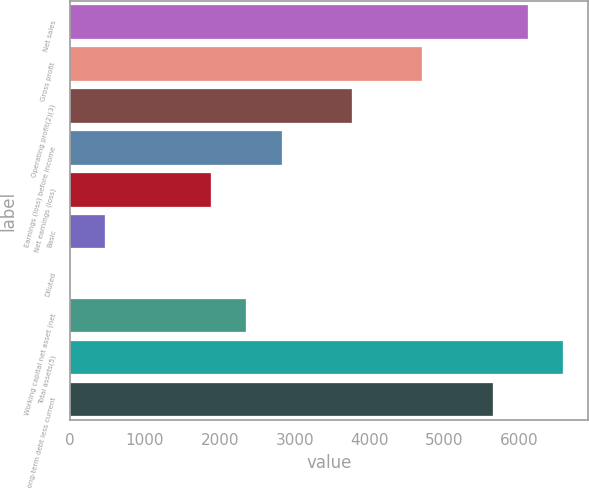Convert chart to OTSL. <chart><loc_0><loc_0><loc_500><loc_500><bar_chart><fcel>Net sales<fcel>Gross profit<fcel>Operating profit(2)(3)<fcel>Earnings (loss) before income<fcel>Net earnings (loss)<fcel>Basic<fcel>Diluted<fcel>Working capital net asset (net<fcel>Total assets(5)<fcel>Long-term debt less current<nl><fcel>6114.7<fcel>4704.07<fcel>3763.65<fcel>2823.23<fcel>1882.81<fcel>472.18<fcel>1.97<fcel>2353.02<fcel>6584.91<fcel>5644.49<nl></chart> 